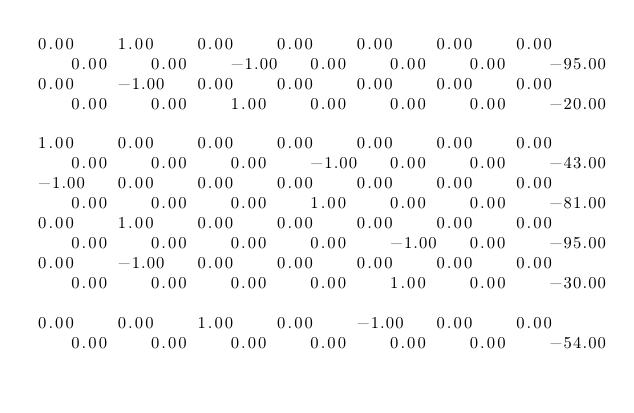Convert code to text. <code><loc_0><loc_0><loc_500><loc_500><_Matlab_>0.00	1.00	0.00	0.00	0.00	0.00	0.00	0.00	0.00	-1.00	0.00	0.00	0.00	-95.00
0.00	-1.00	0.00	0.00	0.00	0.00	0.00	0.00	0.00	1.00	0.00	0.00	0.00	-20.00

1.00	0.00	0.00	0.00	0.00	0.00	0.00	0.00	0.00	0.00	-1.00	0.00	0.00	-43.00
-1.00	0.00	0.00	0.00	0.00	0.00	0.00	0.00	0.00	0.00	1.00	0.00	0.00	-81.00
0.00	1.00	0.00	0.00	0.00	0.00	0.00	0.00	0.00	0.00	0.00	-1.00	0.00	-95.00
0.00	-1.00	0.00	0.00	0.00	0.00	0.00	0.00	0.00	0.00	0.00	1.00	0.00	-30.00

0.00	0.00	1.00	0.00	-1.00	0.00	0.00	0.00	0.00	0.00	0.00	0.00	0.00	-54.00</code> 